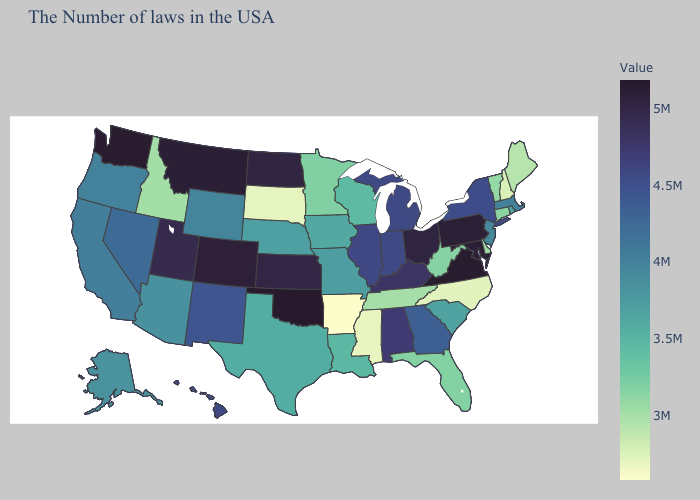Does the map have missing data?
Answer briefly. No. Does Arkansas have the lowest value in the USA?
Quick response, please. Yes. Is the legend a continuous bar?
Give a very brief answer. Yes. Among the states that border Louisiana , does Texas have the highest value?
Concise answer only. Yes. Among the states that border Arkansas , which have the highest value?
Quick response, please. Oklahoma. Does Arkansas have the lowest value in the South?
Keep it brief. Yes. 